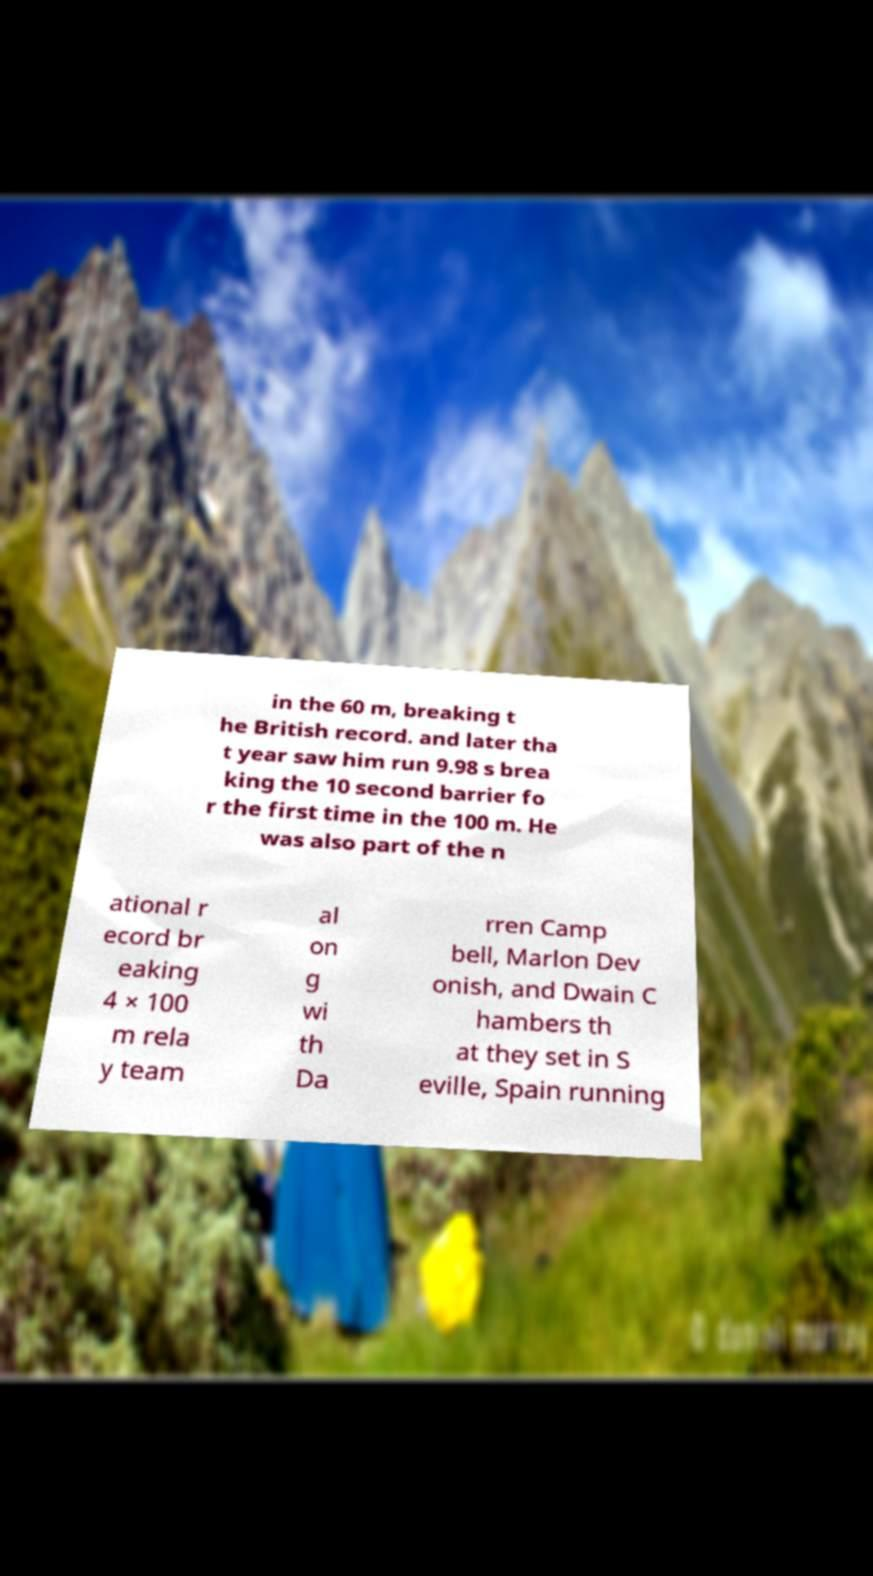Please identify and transcribe the text found in this image. in the 60 m, breaking t he British record. and later tha t year saw him run 9.98 s brea king the 10 second barrier fo r the first time in the 100 m. He was also part of the n ational r ecord br eaking 4 × 100 m rela y team al on g wi th Da rren Camp bell, Marlon Dev onish, and Dwain C hambers th at they set in S eville, Spain running 